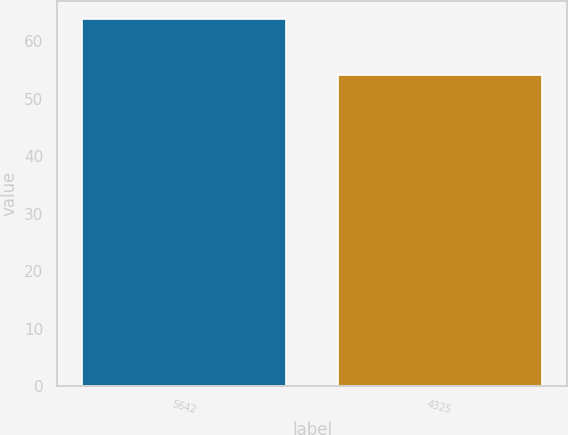Convert chart to OTSL. <chart><loc_0><loc_0><loc_500><loc_500><bar_chart><fcel>5642<fcel>4325<nl><fcel>63.87<fcel>54.1<nl></chart> 